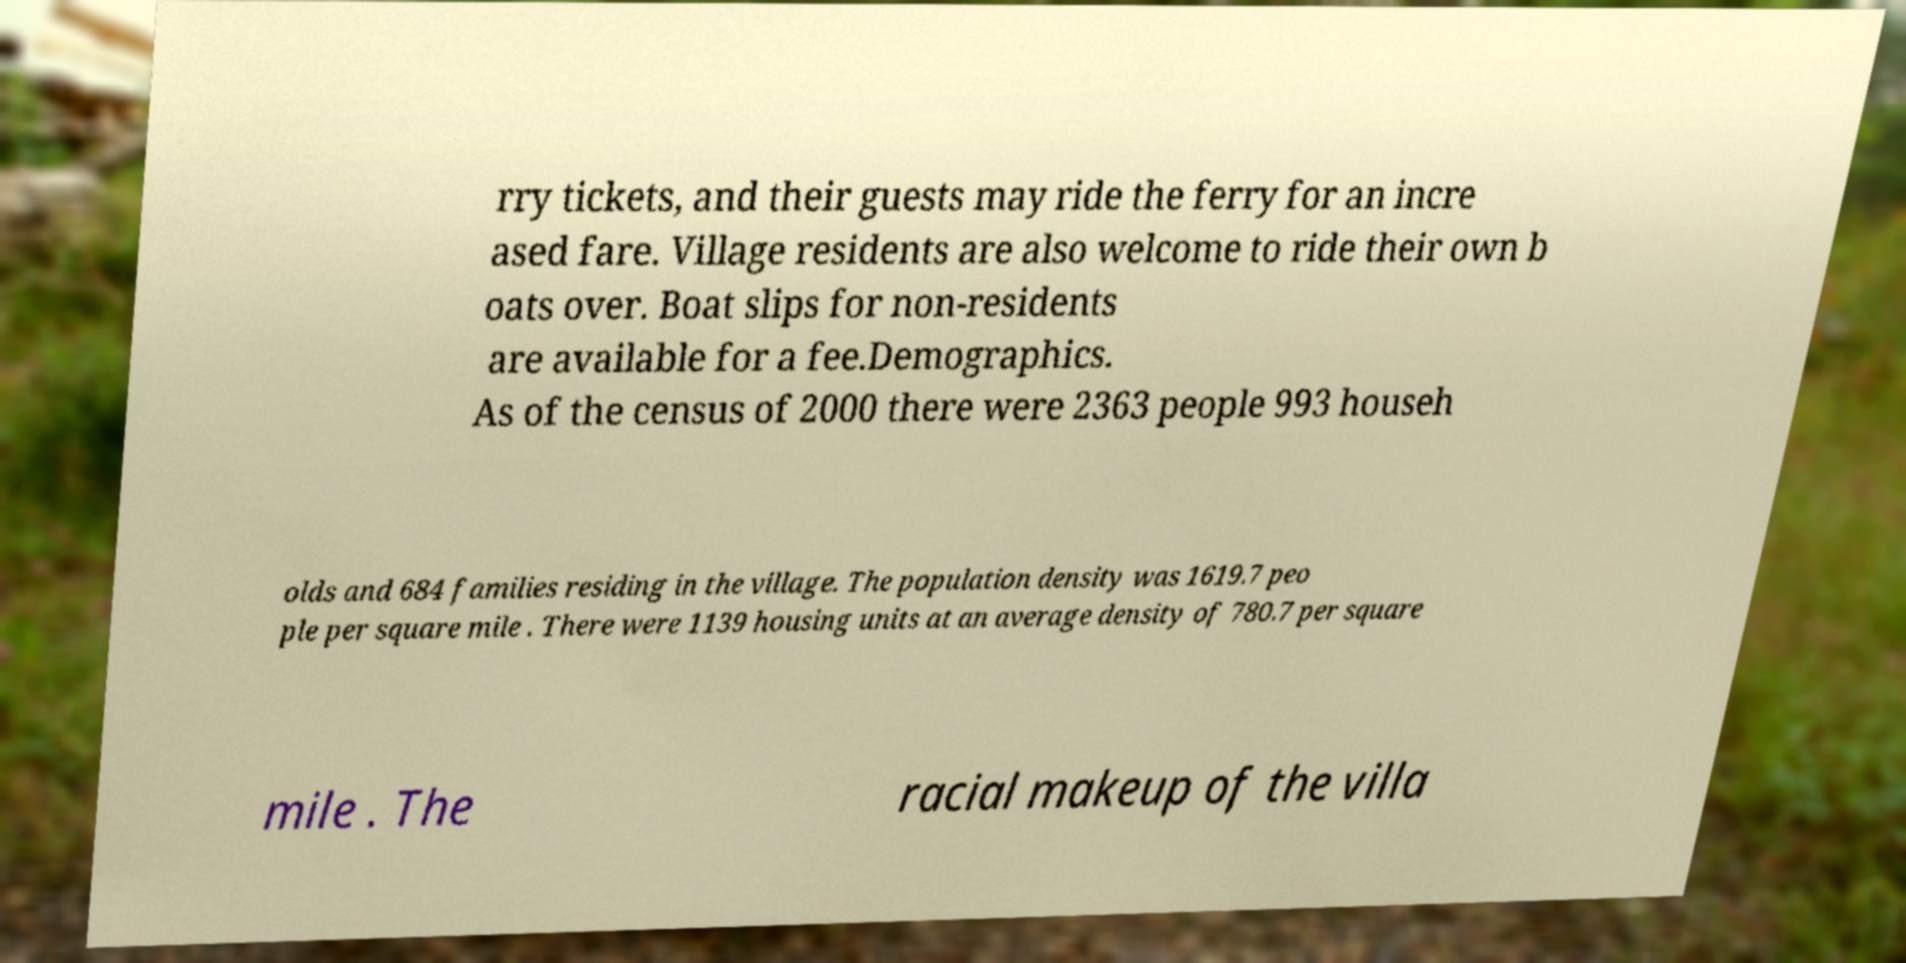There's text embedded in this image that I need extracted. Can you transcribe it verbatim? rry tickets, and their guests may ride the ferry for an incre ased fare. Village residents are also welcome to ride their own b oats over. Boat slips for non-residents are available for a fee.Demographics. As of the census of 2000 there were 2363 people 993 househ olds and 684 families residing in the village. The population density was 1619.7 peo ple per square mile . There were 1139 housing units at an average density of 780.7 per square mile . The racial makeup of the villa 